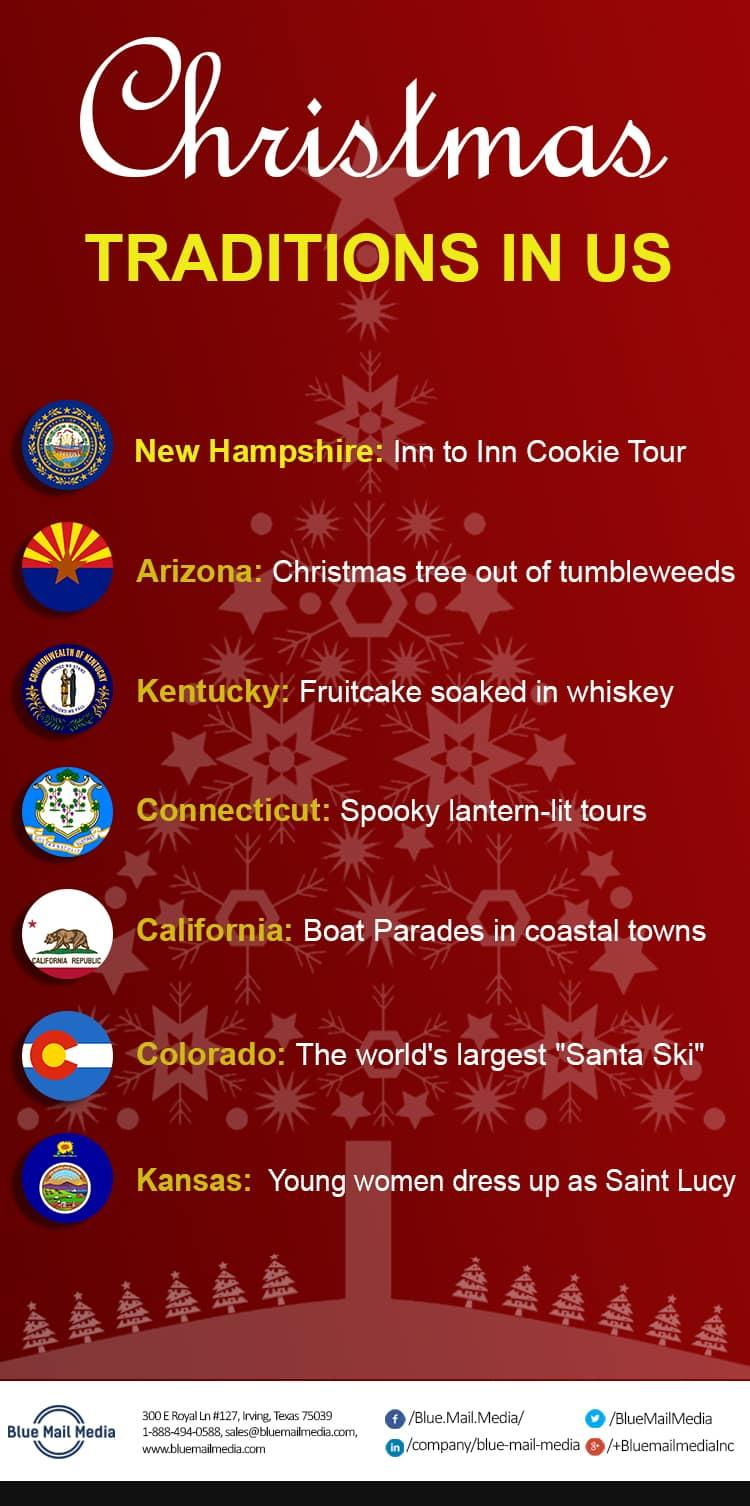Give some essential details in this illustration. The location of Blue Media is Texas, as declared. The color in which the states are written is yellow, not red. The flag of California displays the inscription "California Republic," which is a declaration of the state's status as an independent and self-governing entity. 